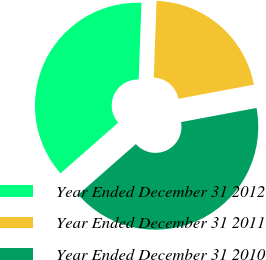Convert chart. <chart><loc_0><loc_0><loc_500><loc_500><pie_chart><fcel>Year Ended December 31 2012<fcel>Year Ended December 31 2011<fcel>Year Ended December 31 2010<nl><fcel>37.05%<fcel>21.48%<fcel>41.48%<nl></chart> 